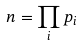Convert formula to latex. <formula><loc_0><loc_0><loc_500><loc_500>n = \prod _ { i } p _ { i }</formula> 